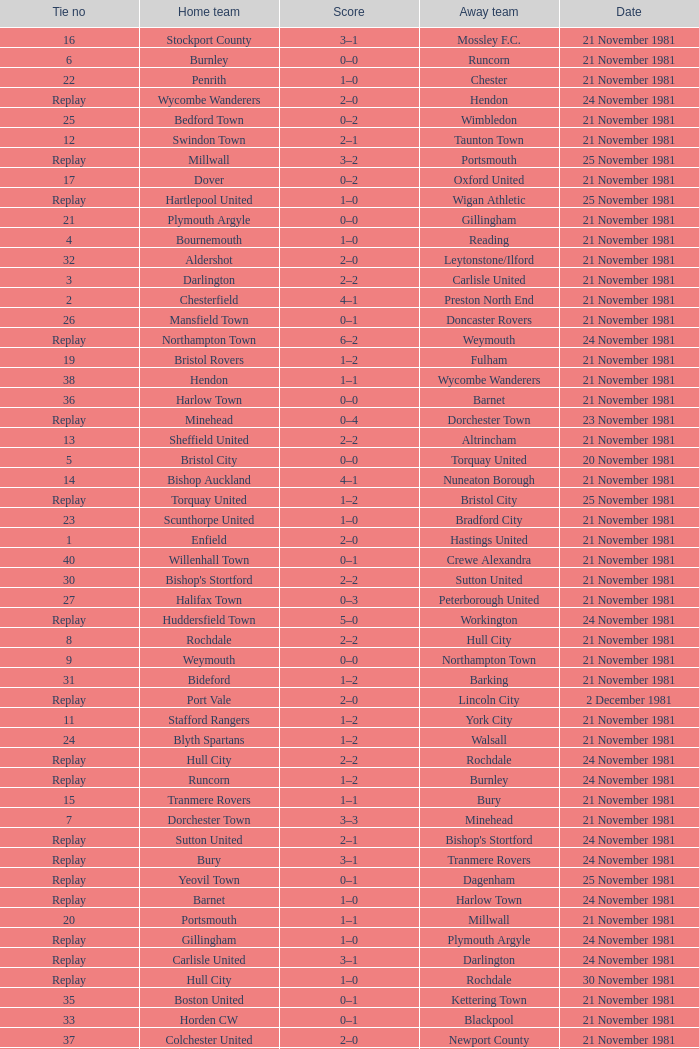Minehead has what tie number? Replay. 